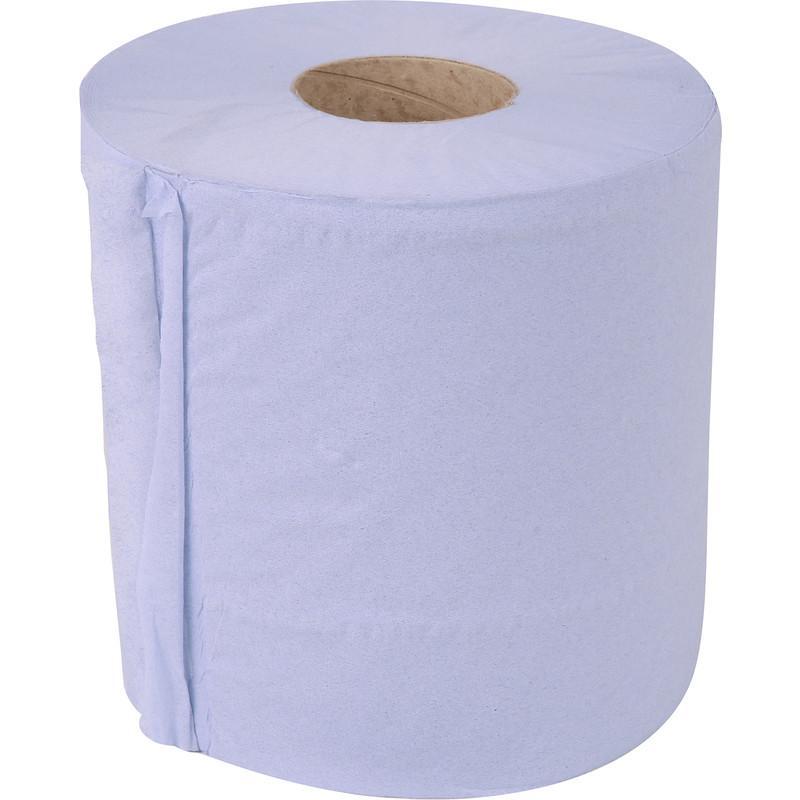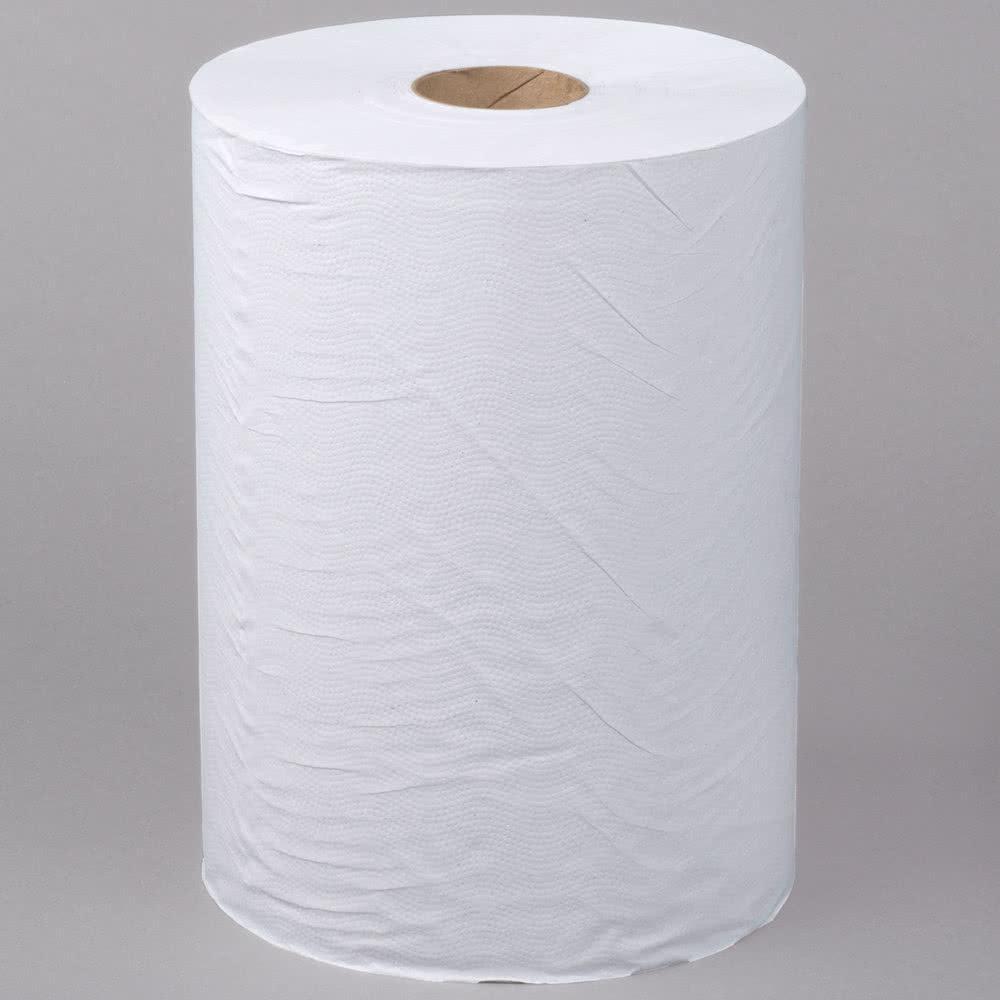The first image is the image on the left, the second image is the image on the right. Given the left and right images, does the statement "At least 1 roll is standing vertically." hold true? Answer yes or no. Yes. 